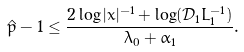Convert formula to latex. <formula><loc_0><loc_0><loc_500><loc_500>\hat { p } - 1 \leq \frac { 2 \log | x | ^ { - 1 } + \log ( \mathcal { D } _ { 1 } L _ { 1 } ^ { - 1 } ) } { \lambda _ { 0 } + \alpha _ { 1 } } .</formula> 